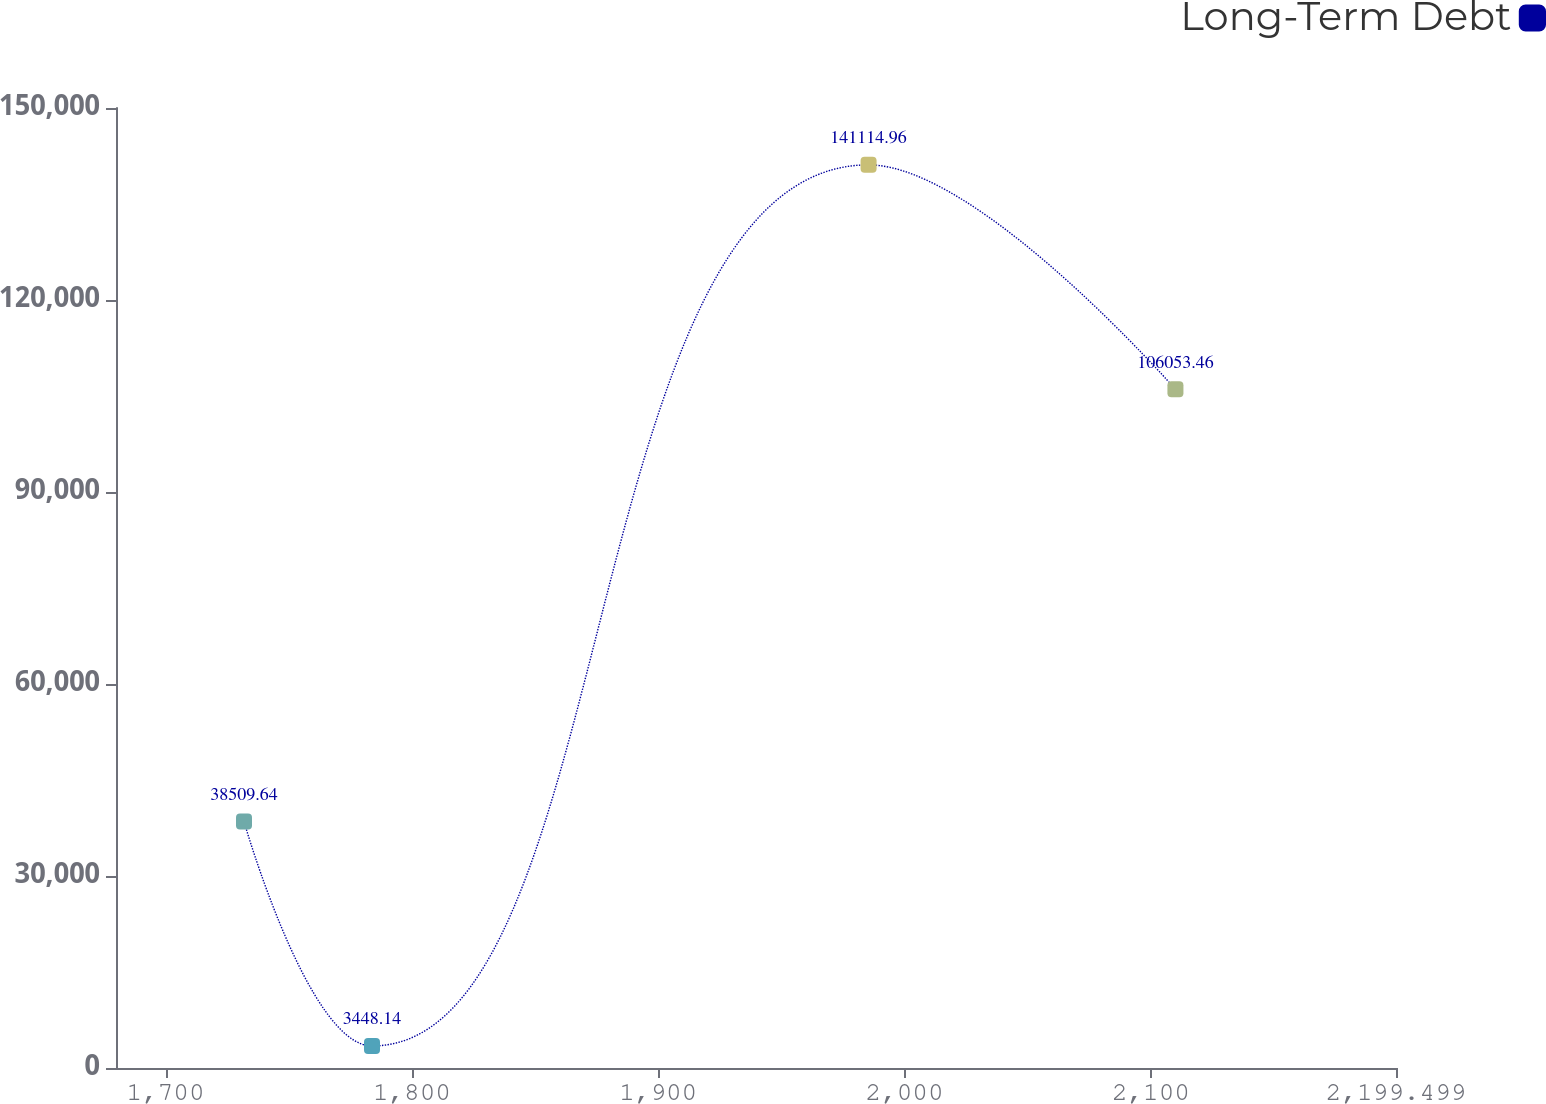<chart> <loc_0><loc_0><loc_500><loc_500><line_chart><ecel><fcel>Long-Term Debt<nl><fcel>1731.85<fcel>38509.6<nl><fcel>1783.81<fcel>3448.14<nl><fcel>1985.4<fcel>141115<nl><fcel>2109.96<fcel>106053<nl><fcel>2251.46<fcel>354063<nl></chart> 